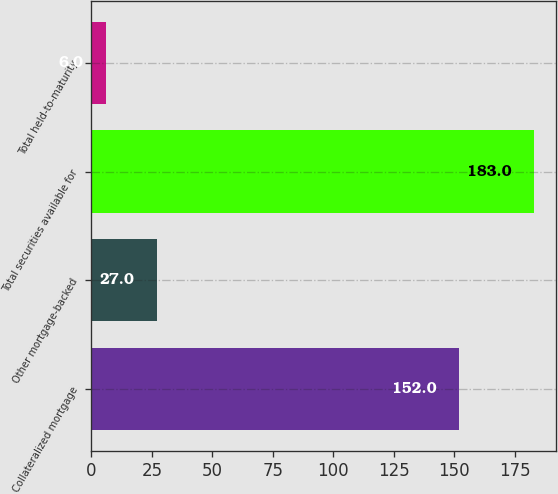<chart> <loc_0><loc_0><loc_500><loc_500><bar_chart><fcel>Collateralized mortgage<fcel>Other mortgage-backed<fcel>Total securities available for<fcel>Total held-to-maturity<nl><fcel>152<fcel>27<fcel>183<fcel>6<nl></chart> 